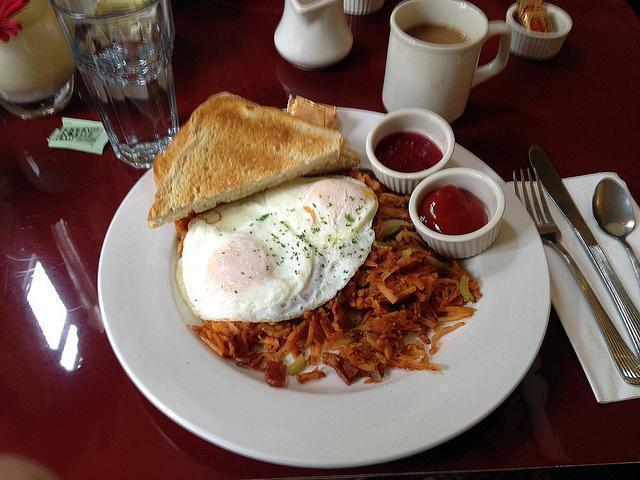What time of day is most likely?
Choose the correct response, then elucidate: 'Answer: answer
Rationale: rationale.'
Options: Night, evening, afternoon, morning. Answer: morning.
Rationale: The plate contains foods that are normally served at breakfast in the morning such as eggs and toast. 